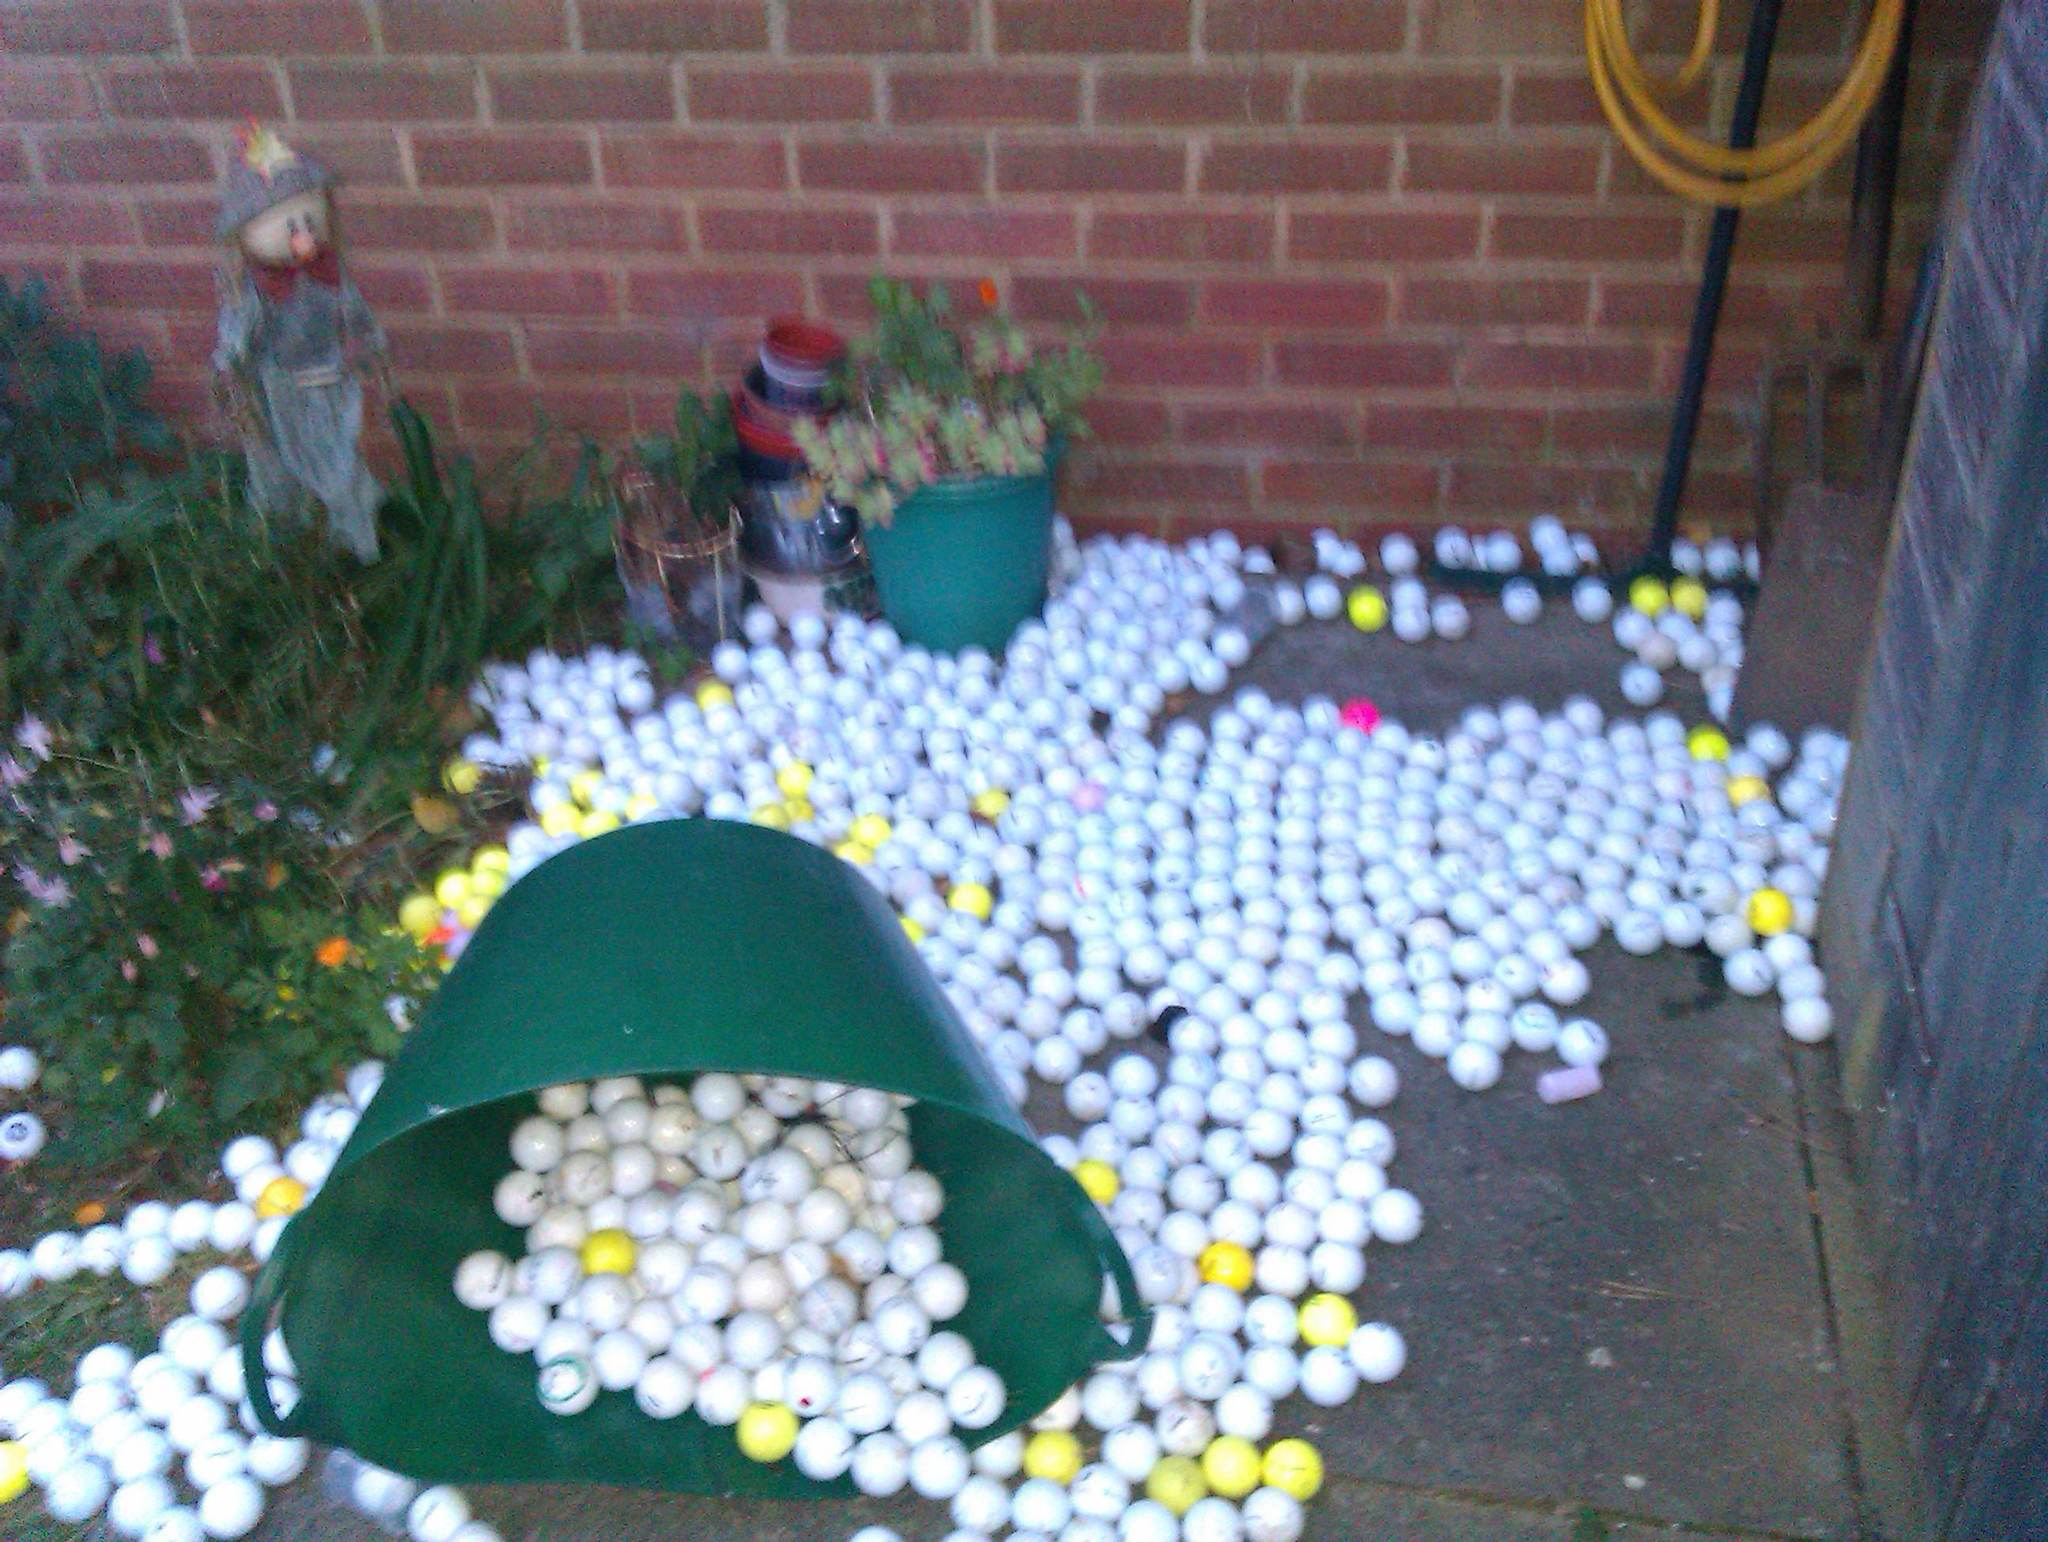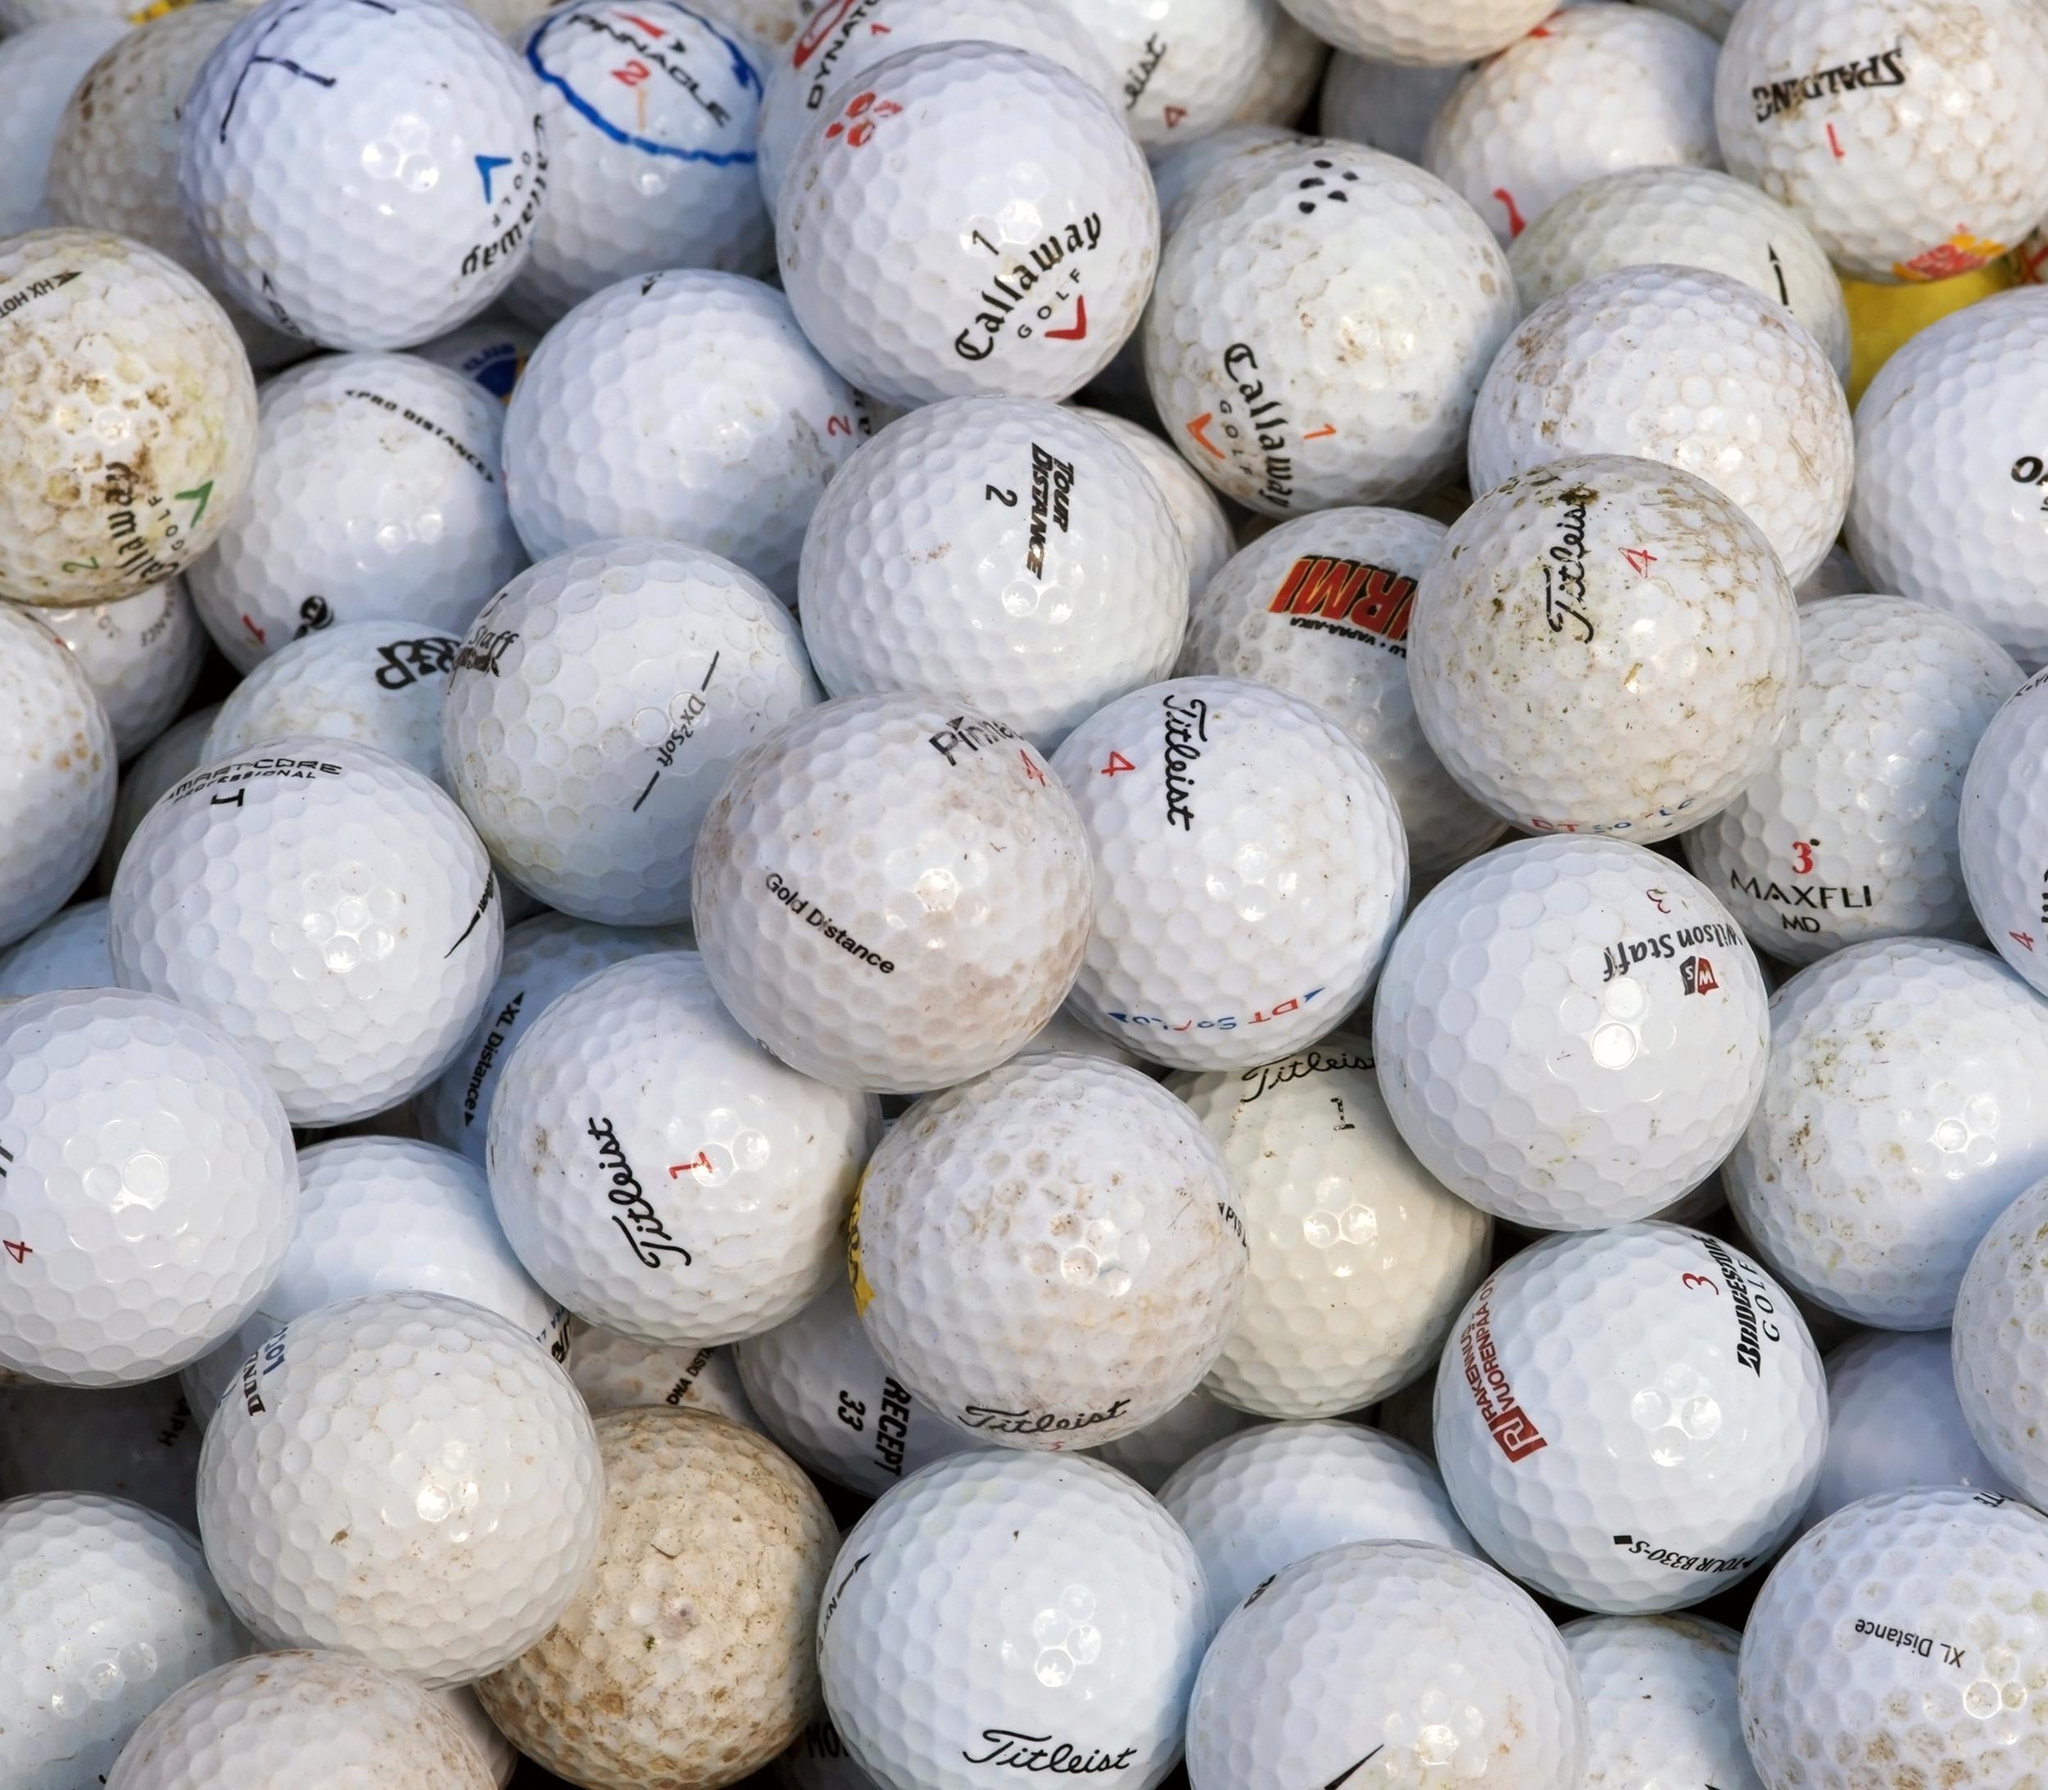The first image is the image on the left, the second image is the image on the right. Examine the images to the left and right. Is the description "An image features a tipped-over mesh-type bucket spilling golf balls." accurate? Answer yes or no. No. The first image is the image on the left, the second image is the image on the right. Examine the images to the left and right. Is the description "Balls are pouring out of a mesh green basket." accurate? Answer yes or no. No. 